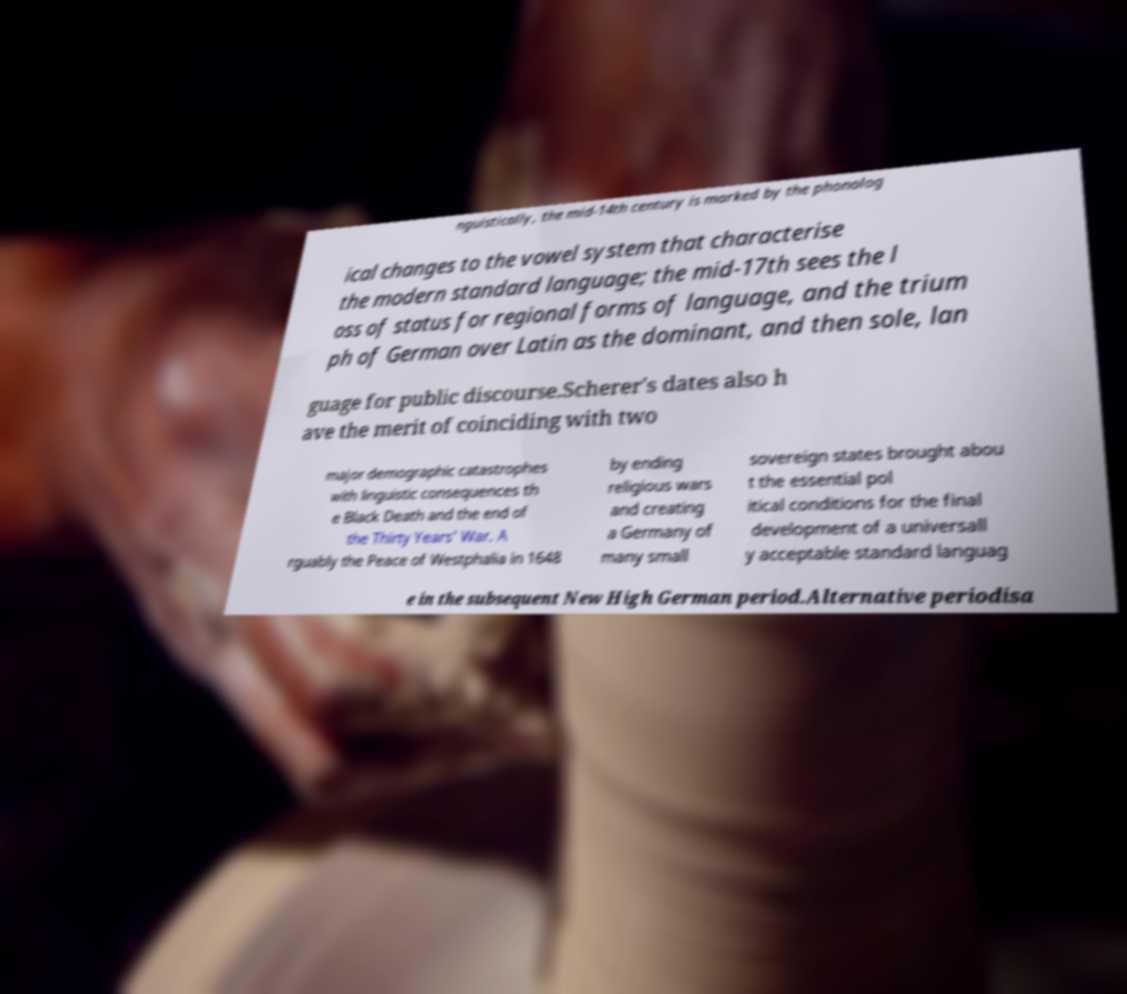There's text embedded in this image that I need extracted. Can you transcribe it verbatim? nguistically, the mid-14th century is marked by the phonolog ical changes to the vowel system that characterise the modern standard language; the mid-17th sees the l oss of status for regional forms of language, and the trium ph of German over Latin as the dominant, and then sole, lan guage for public discourse.Scherer's dates also h ave the merit of coinciding with two major demographic catastrophes with linguistic consequences th e Black Death and the end of the Thirty Years' War. A rguably the Peace of Westphalia in 1648 by ending religious wars and creating a Germany of many small sovereign states brought abou t the essential pol itical conditions for the final development of a universall y acceptable standard languag e in the subsequent New High German period.Alternative periodisa 